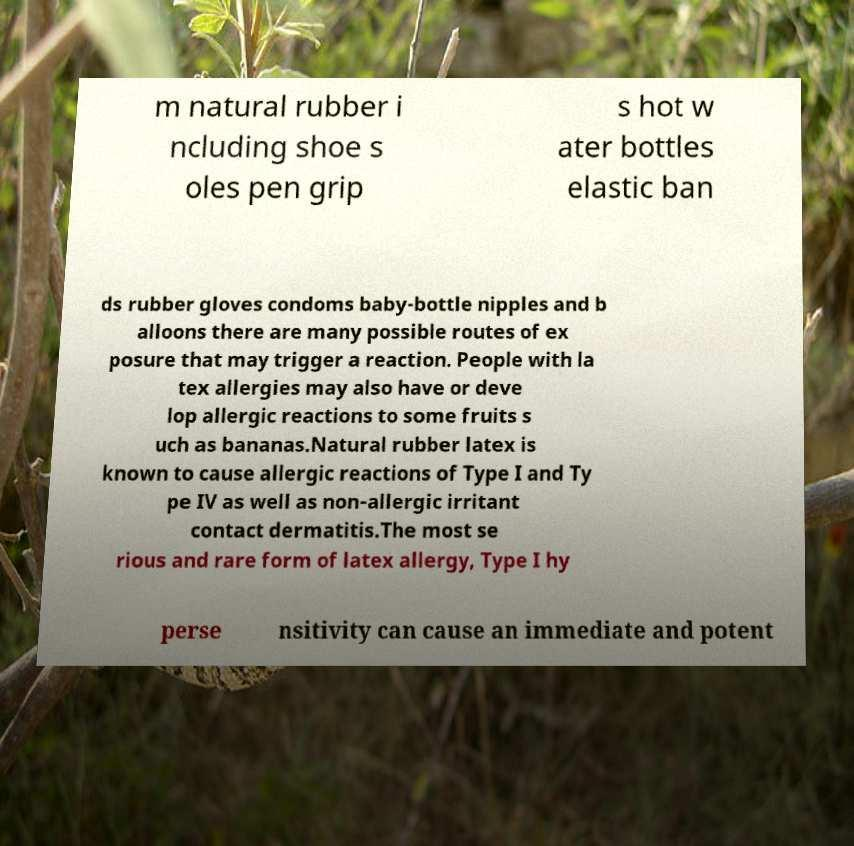For documentation purposes, I need the text within this image transcribed. Could you provide that? m natural rubber i ncluding shoe s oles pen grip s hot w ater bottles elastic ban ds rubber gloves condoms baby-bottle nipples and b alloons there are many possible routes of ex posure that may trigger a reaction. People with la tex allergies may also have or deve lop allergic reactions to some fruits s uch as bananas.Natural rubber latex is known to cause allergic reactions of Type I and Ty pe IV as well as non-allergic irritant contact dermatitis.The most se rious and rare form of latex allergy, Type I hy perse nsitivity can cause an immediate and potent 